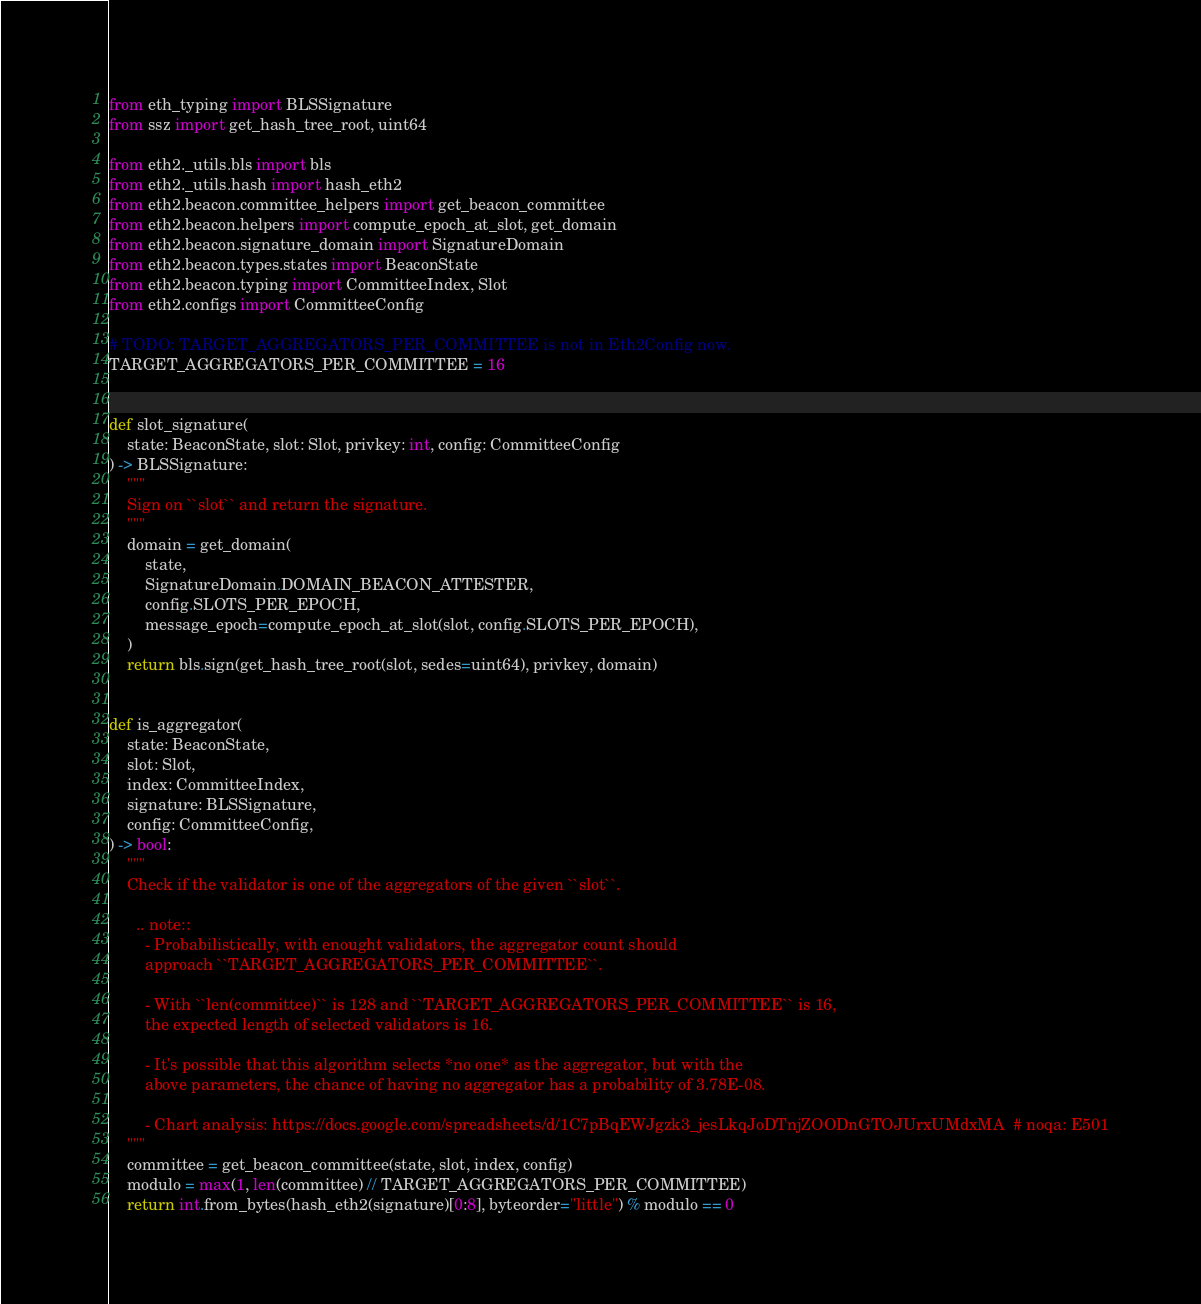Convert code to text. <code><loc_0><loc_0><loc_500><loc_500><_Python_>from eth_typing import BLSSignature
from ssz import get_hash_tree_root, uint64

from eth2._utils.bls import bls
from eth2._utils.hash import hash_eth2
from eth2.beacon.committee_helpers import get_beacon_committee
from eth2.beacon.helpers import compute_epoch_at_slot, get_domain
from eth2.beacon.signature_domain import SignatureDomain
from eth2.beacon.types.states import BeaconState
from eth2.beacon.typing import CommitteeIndex, Slot
from eth2.configs import CommitteeConfig

# TODO: TARGET_AGGREGATORS_PER_COMMITTEE is not in Eth2Config now.
TARGET_AGGREGATORS_PER_COMMITTEE = 16


def slot_signature(
    state: BeaconState, slot: Slot, privkey: int, config: CommitteeConfig
) -> BLSSignature:
    """
    Sign on ``slot`` and return the signature.
    """
    domain = get_domain(
        state,
        SignatureDomain.DOMAIN_BEACON_ATTESTER,
        config.SLOTS_PER_EPOCH,
        message_epoch=compute_epoch_at_slot(slot, config.SLOTS_PER_EPOCH),
    )
    return bls.sign(get_hash_tree_root(slot, sedes=uint64), privkey, domain)


def is_aggregator(
    state: BeaconState,
    slot: Slot,
    index: CommitteeIndex,
    signature: BLSSignature,
    config: CommitteeConfig,
) -> bool:
    """
    Check if the validator is one of the aggregators of the given ``slot``.

      .. note::
        - Probabilistically, with enought validators, the aggregator count should
        approach ``TARGET_AGGREGATORS_PER_COMMITTEE``.

        - With ``len(committee)`` is 128 and ``TARGET_AGGREGATORS_PER_COMMITTEE`` is 16,
        the expected length of selected validators is 16.

        - It's possible that this algorithm selects *no one* as the aggregator, but with the
        above parameters, the chance of having no aggregator has a probability of 3.78E-08.

        - Chart analysis: https://docs.google.com/spreadsheets/d/1C7pBqEWJgzk3_jesLkqJoDTnjZOODnGTOJUrxUMdxMA  # noqa: E501
    """
    committee = get_beacon_committee(state, slot, index, config)
    modulo = max(1, len(committee) // TARGET_AGGREGATORS_PER_COMMITTEE)
    return int.from_bytes(hash_eth2(signature)[0:8], byteorder="little") % modulo == 0
</code> 